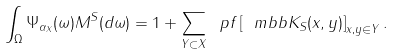Convert formula to latex. <formula><loc_0><loc_0><loc_500><loc_500>\int _ { \Omega } \Psi _ { \alpha _ { X } } ( \omega ) M ^ { S } ( d \omega ) = 1 + \sum _ { Y \subset X } \ p f \left [ \ m b b { K } _ { S } ( x , y ) \right ] _ { x , y \in Y } .</formula> 